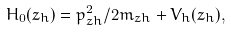Convert formula to latex. <formula><loc_0><loc_0><loc_500><loc_500>H _ { 0 } ( z _ { h } ) = p _ { z h } ^ { 2 } / 2 m _ { z h } + V _ { h } ( z _ { h } ) ,</formula> 